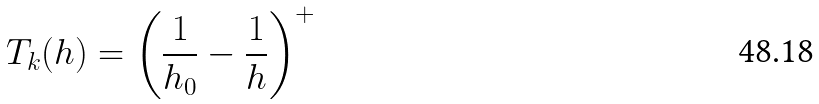<formula> <loc_0><loc_0><loc_500><loc_500>T _ { k } ( h ) = \left ( \frac { 1 } { h _ { 0 } } - \frac { 1 } { h } \right ) ^ { + }</formula> 